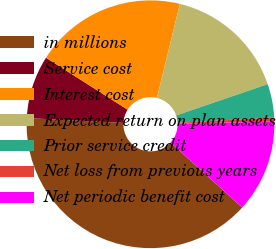<chart> <loc_0><loc_0><loc_500><loc_500><pie_chart><fcel>in millions<fcel>Service cost<fcel>Interest cost<fcel>Expected return on plan assets<fcel>Prior service credit<fcel>Net loss from previous years<fcel>Net periodic benefit cost<nl><fcel>39.06%<fcel>8.23%<fcel>19.79%<fcel>15.94%<fcel>4.38%<fcel>0.52%<fcel>12.08%<nl></chart> 